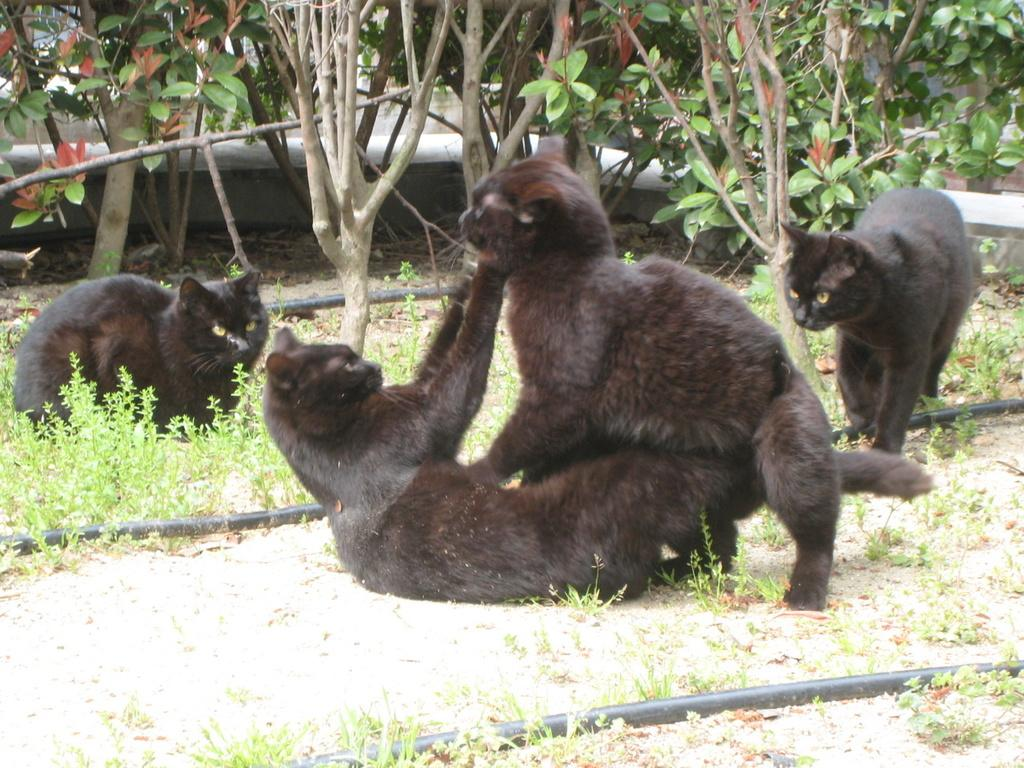What is located in the foreground of the picture? There are cats, plants, pipes, and soil in the foreground of the picture. What type of vegetation can be seen in the foreground of the picture? There are plants in the foreground of the picture. What is the material of the pipes in the foreground of the picture? The material of the pipes is not specified in the facts, but they are visible in the foreground. What is visible in the background of the picture? There are trees, soil, and pavement in the background of the picture. What type of surface is present in the background of the picture? There is pavement in the background of the picture. How is the land connected to the yoke in the image? There is no land or yoke present in the image. What type of yoke is being used by the cats in the image? There are no yokes present in the image, and the cats are not using any yokes. 